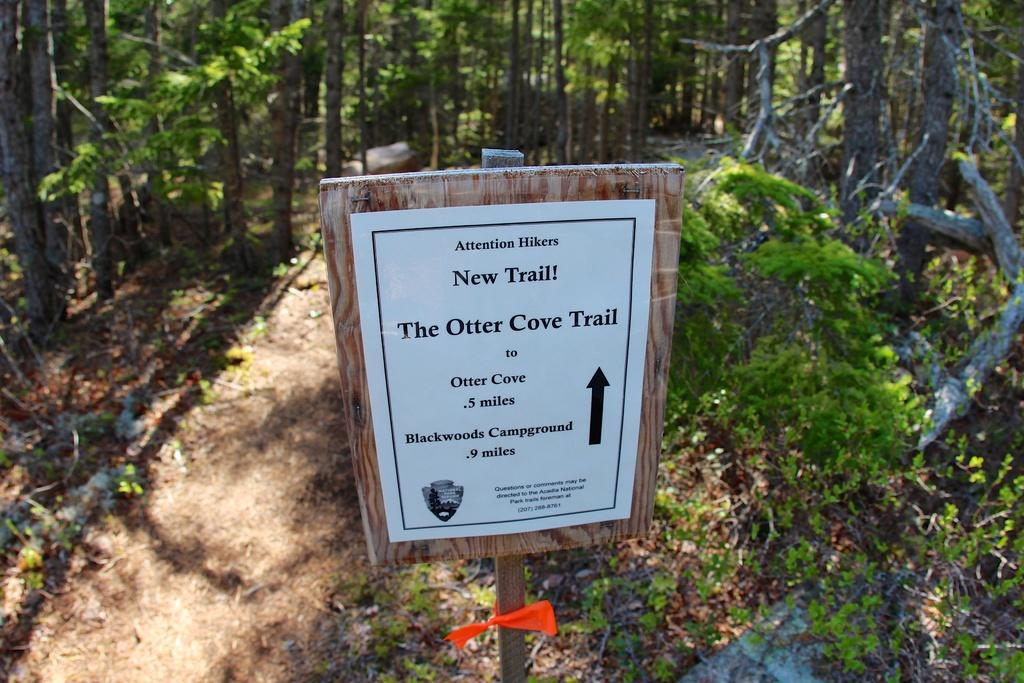What is the main object in the picture? There is a board in the picture. What is attached to the board? There is a paper pasted on the board. What can be seen in the background of the picture? There are plants and trees in the backdrop of the picture. What type of curtain is hanging from the crook in the image? There is no curtain or crook present in the image. 